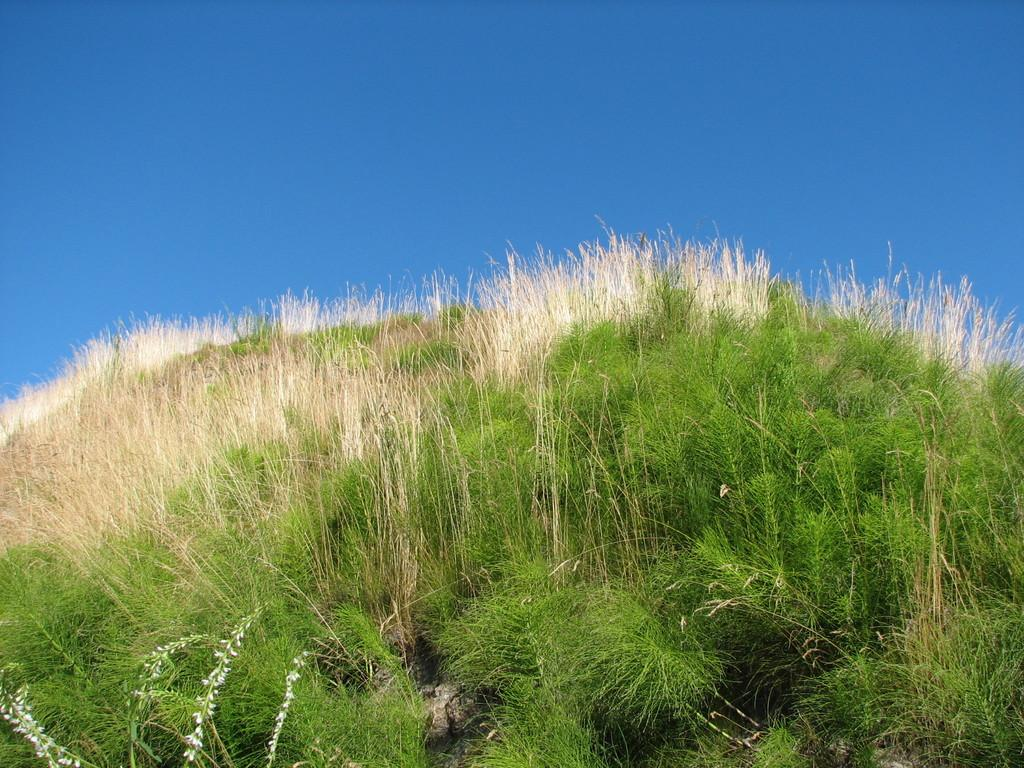What type of vegetation is present at the bottom of the image? There is grass and plants at the bottom of the image. What part of the natural environment is visible at the top of the image? The sky is visible at the top of the image. How many friends are sitting on the rod in the image? There is no rod or friends present in the image. What type of ducks can be seen swimming in the water in the image? There is no water or ducks present in the image. 